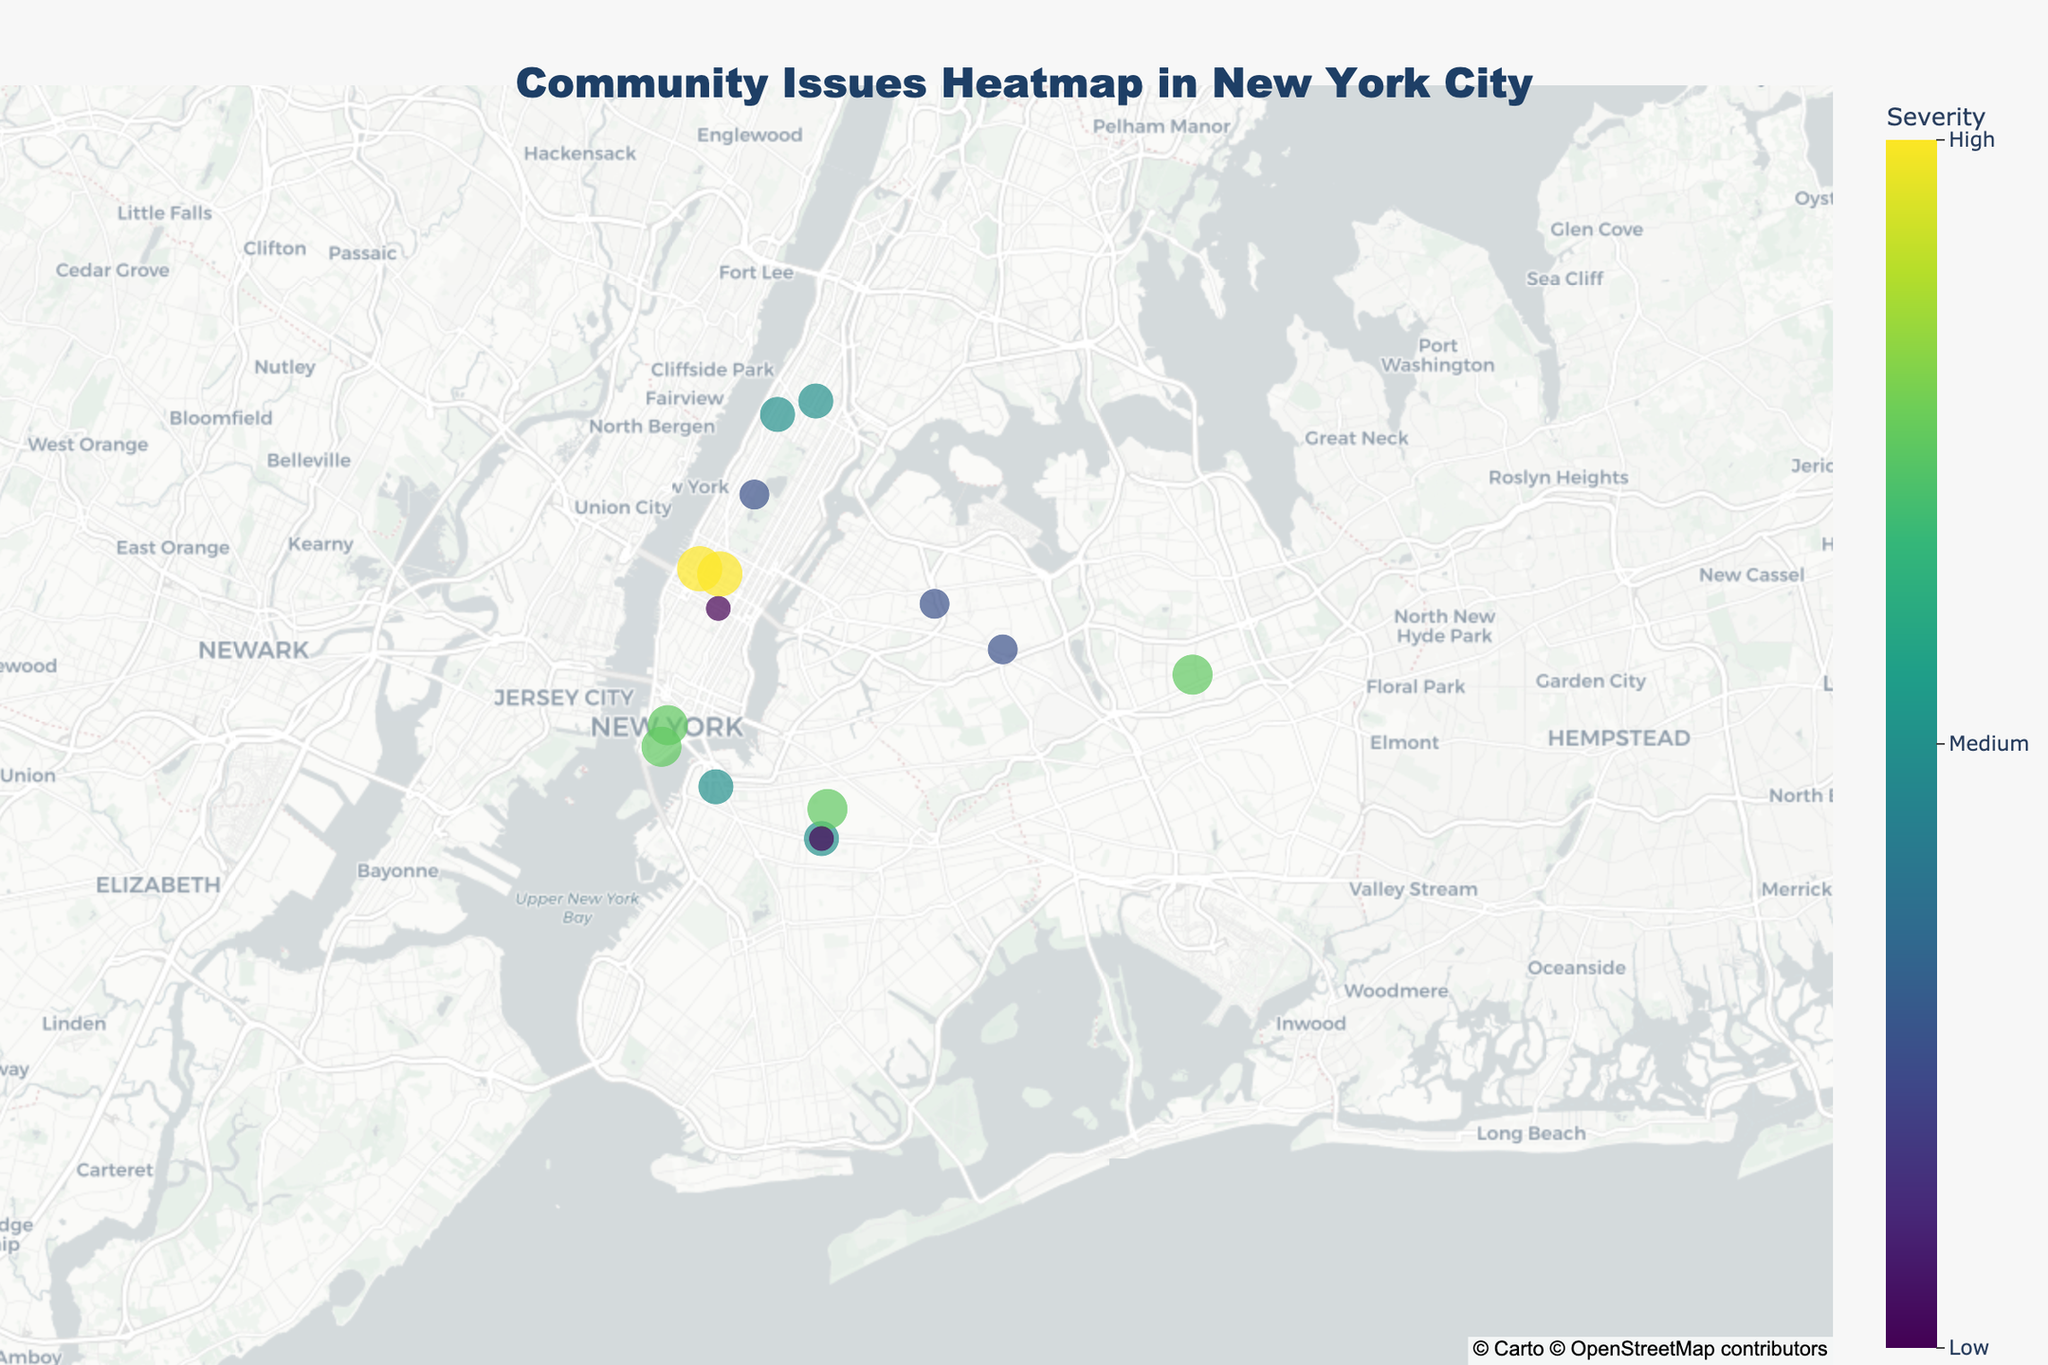what is the main title of the plot? The main title is displayed at the top center of the plot. It includes information about the data being presented. Look for the largest text, styled prominently.
Answer: Community Issues Heatmap in New York City how many areas are reported with issues? Count the number of data points (markers) on the plot. Each marker represents one area with a reported issue.
Answer: 15 which area reported the highest severity issue and what was the issue? Locate the marker with the largest size and the highest color intensity in the color scale. Check its corresponding text.
Answer: Midtown, Traffic congestion which areas reported a severity of 8? Identify markers that match the color scale for severity '8'. Read their corresponding text for area names.
Answer: Lower Manhattan, Jamaica, Fort Greene, Battery Park City which issue has the lowest severity reported, and in what area? Look for the smallest marker or the one with the least intensity on the color scale. Check its text for the issue and area.
Answer: Murray Hill, Restaurant noise which area has a higher severity issue, DUMBO or Park Slope? Compare the severity values for DUMBO and Park Slope by referring to their markers. Verify by reading their text.
Answer: DUMBO (7) which two areas have the same issue reported but with different severities? Check the text for repeated issues among different markers.
Answer: Lower Manhattan and Murray Hill (Noise pollution: 8 and 5) what kind of issue was reported in Hell's Kitchen, and how severe is it? Look for the marker in Hell's Kitchen and read its text for both the issue and severity.
Answer: Homelessness, 9 